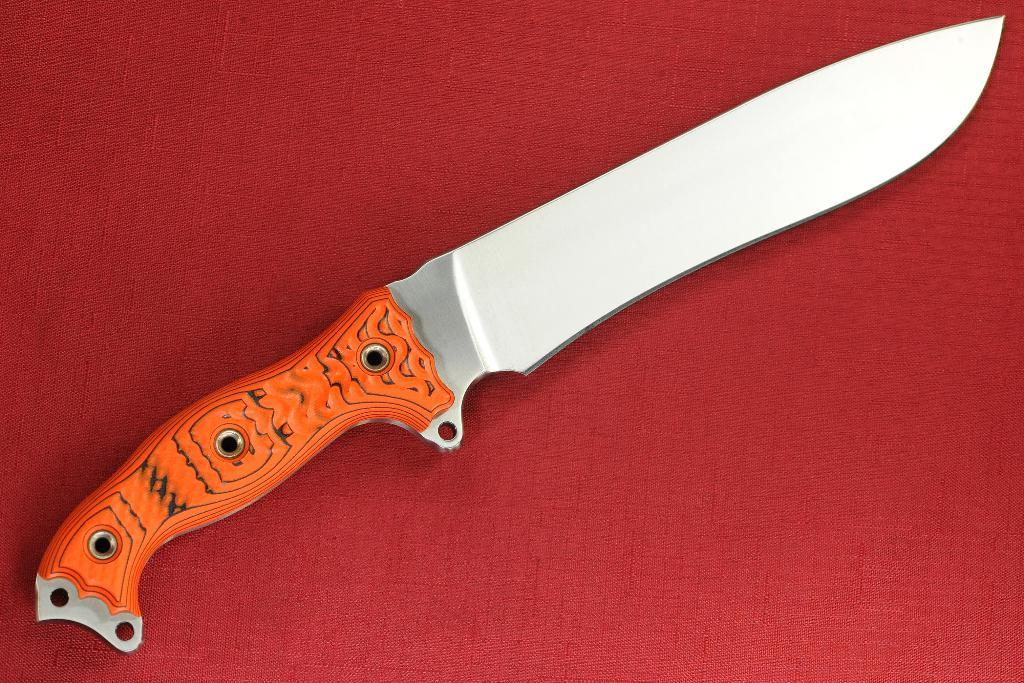What object is present in the image that can be used for cutting? There is a knife in the image. What is the color of the holder in the image? The holder in the image has an orange color. What is the holder placed on in the image? The orange color holder is placed on a red color mat. What type of harmony can be heard in the image? There is no audible sound or music in the image, so it is not possible to determine if any harmony can be heard. 